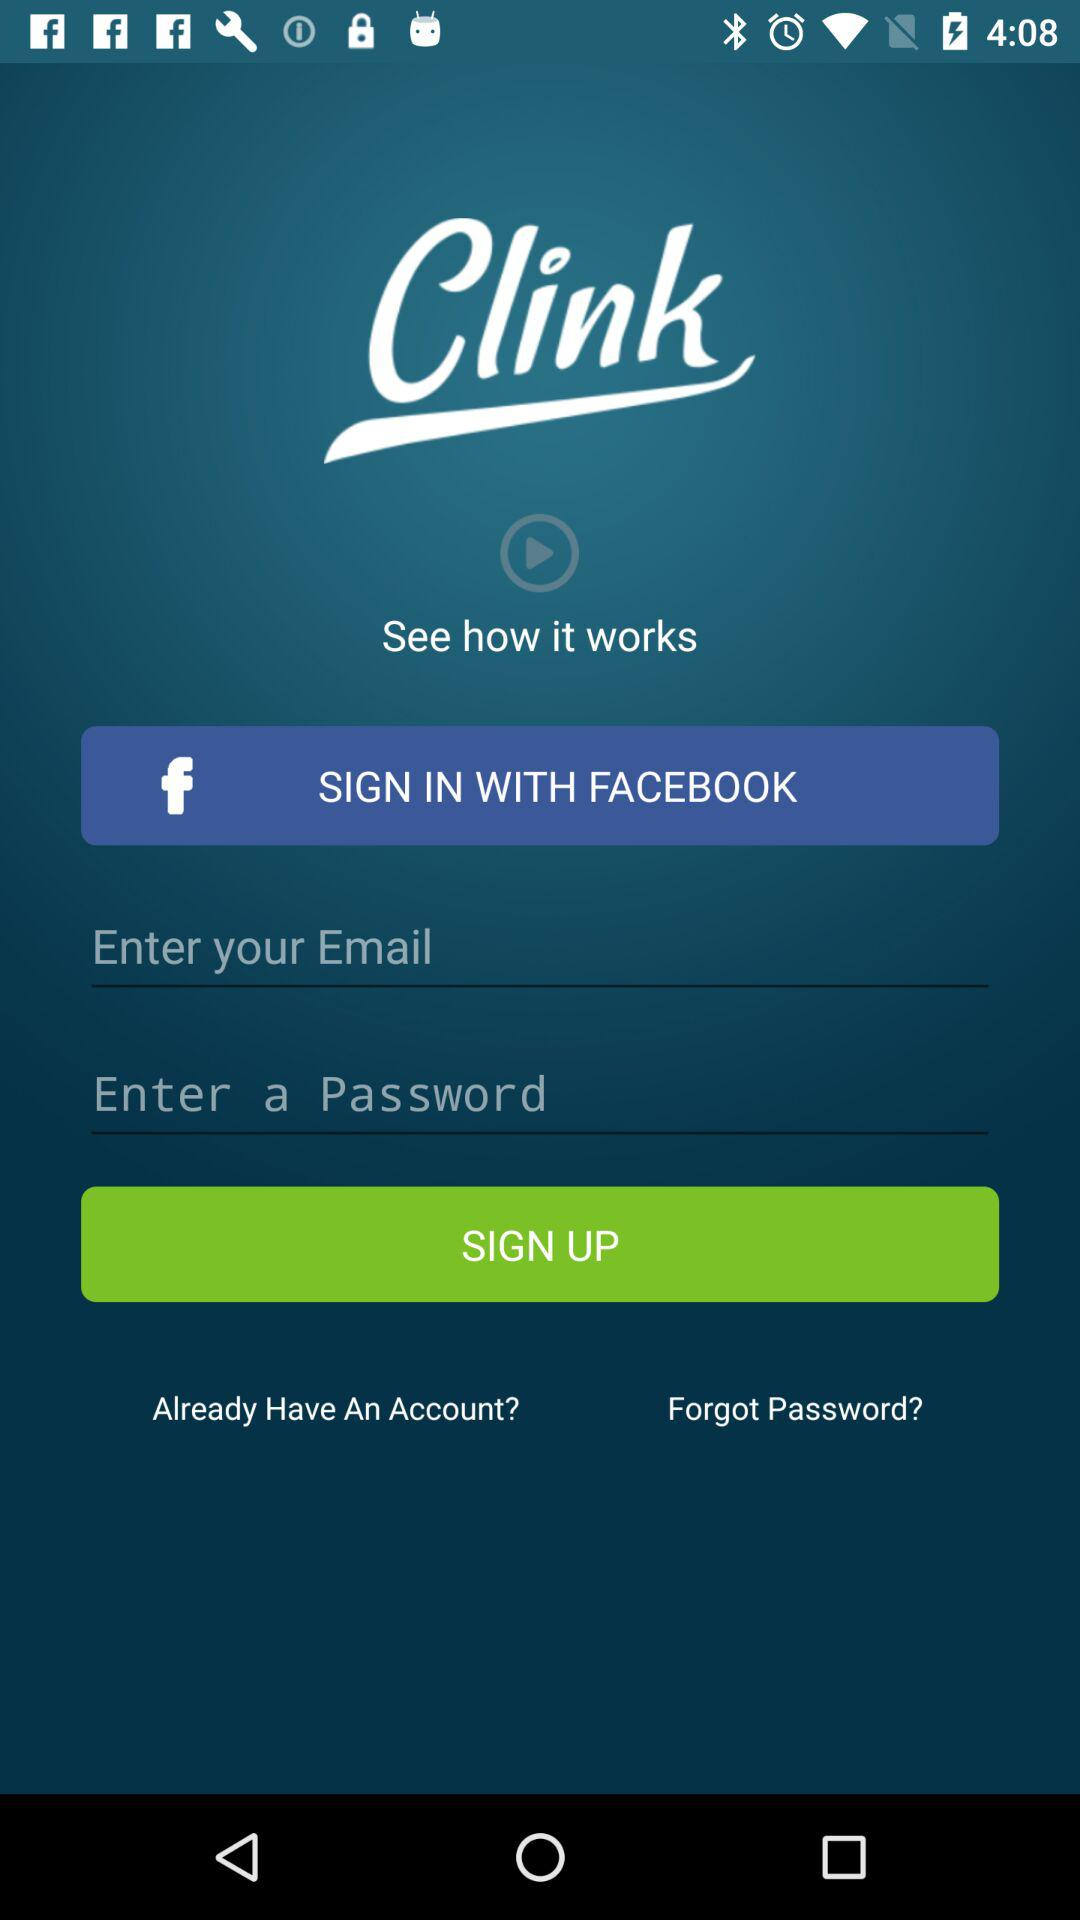What application can we use to sign in? You can use "FACEBOOK" to sign in. 